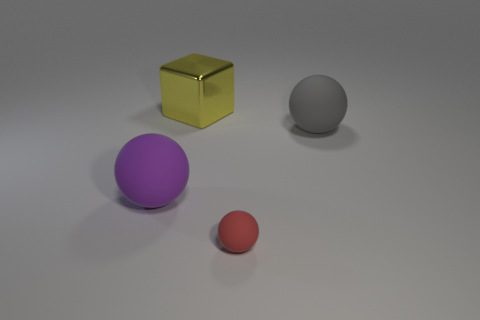Add 3 purple rubber spheres. How many objects exist? 7 Subtract all cubes. How many objects are left? 3 Add 3 metallic cubes. How many metallic cubes are left? 4 Add 3 red balls. How many red balls exist? 4 Subtract 0 purple cylinders. How many objects are left? 4 Subtract all small rubber balls. Subtract all tiny purple objects. How many objects are left? 3 